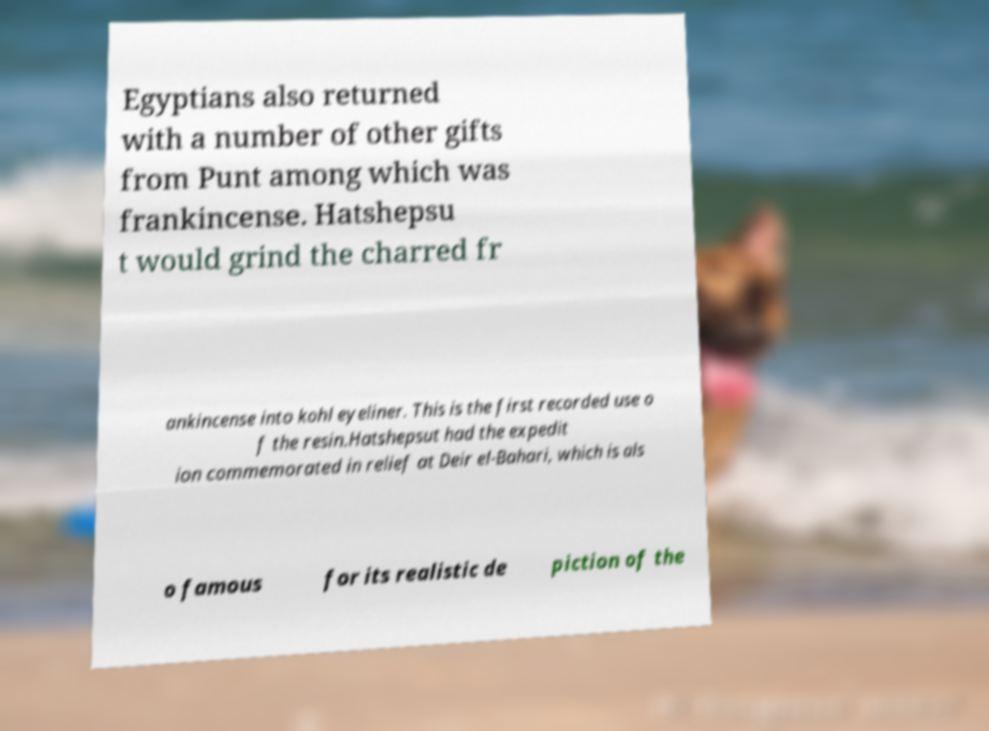Please identify and transcribe the text found in this image. Egyptians also returned with a number of other gifts from Punt among which was frankincense. Hatshepsu t would grind the charred fr ankincense into kohl eyeliner. This is the first recorded use o f the resin.Hatshepsut had the expedit ion commemorated in relief at Deir el-Bahari, which is als o famous for its realistic de piction of the 